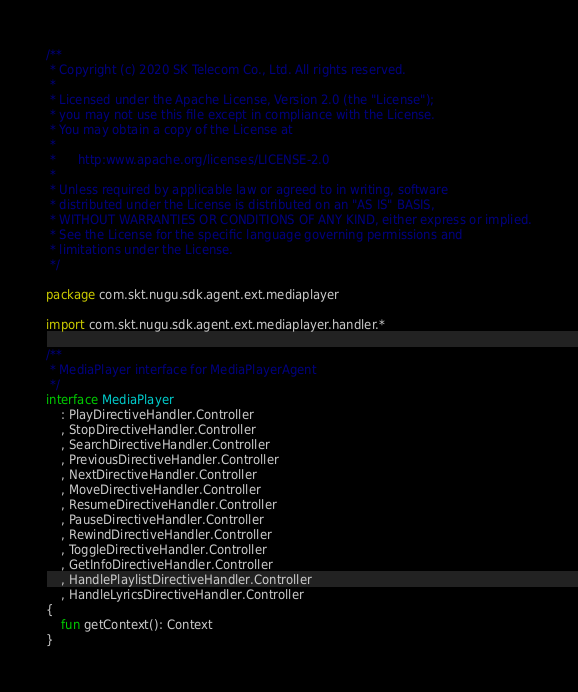Convert code to text. <code><loc_0><loc_0><loc_500><loc_500><_Kotlin_>/**
 * Copyright (c) 2020 SK Telecom Co., Ltd. All rights reserved.
 *
 * Licensed under the Apache License, Version 2.0 (the "License");
 * you may not use this file except in compliance with the License.
 * You may obtain a copy of the License at
 *
 *      http:www.apache.org/licenses/LICENSE-2.0
 *
 * Unless required by applicable law or agreed to in writing, software
 * distributed under the License is distributed on an "AS IS" BASIS,
 * WITHOUT WARRANTIES OR CONDITIONS OF ANY KIND, either express or implied.
 * See the License for the specific language governing permissions and
 * limitations under the License.
 */

package com.skt.nugu.sdk.agent.ext.mediaplayer

import com.skt.nugu.sdk.agent.ext.mediaplayer.handler.*

/**
 * MediaPlayer interface for MediaPlayerAgent
 */
interface MediaPlayer
    : PlayDirectiveHandler.Controller
    , StopDirectiveHandler.Controller
    , SearchDirectiveHandler.Controller
    , PreviousDirectiveHandler.Controller
    , NextDirectiveHandler.Controller
    , MoveDirectiveHandler.Controller
    , ResumeDirectiveHandler.Controller
    , PauseDirectiveHandler.Controller
    , RewindDirectiveHandler.Controller
    , ToggleDirectiveHandler.Controller
    , GetInfoDirectiveHandler.Controller
    , HandlePlaylistDirectiveHandler.Controller
    , HandleLyricsDirectiveHandler.Controller
{
    fun getContext(): Context
}</code> 